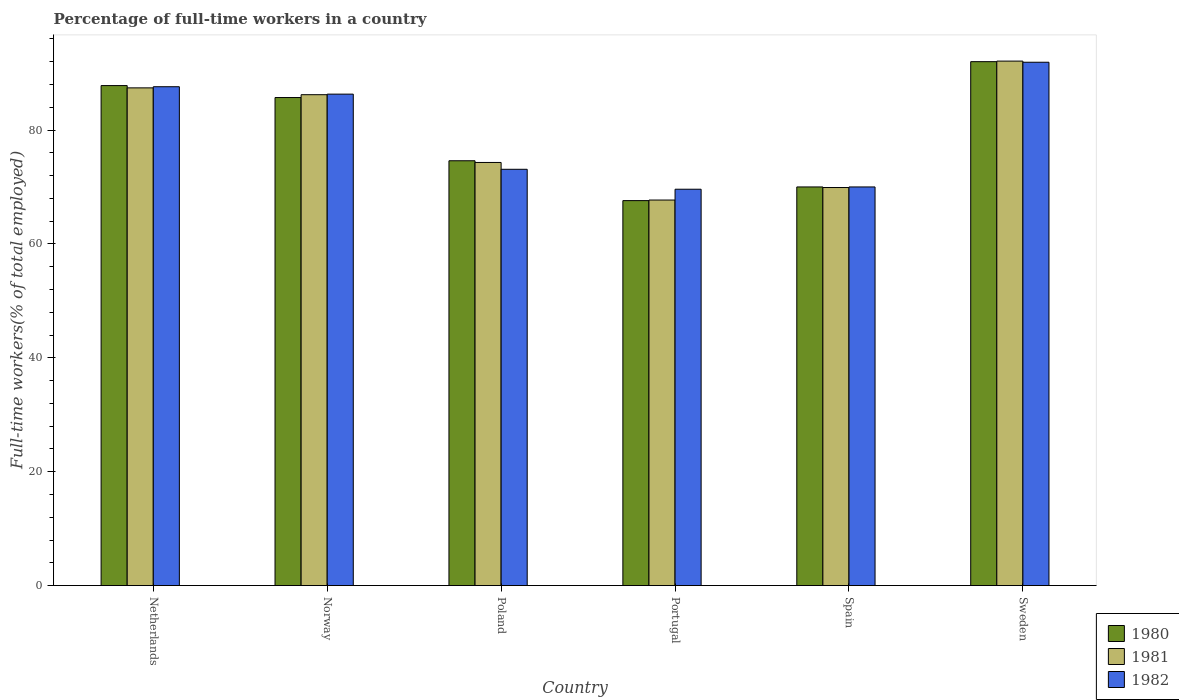How many different coloured bars are there?
Your answer should be very brief. 3. Are the number of bars on each tick of the X-axis equal?
Keep it short and to the point. Yes. How many bars are there on the 3rd tick from the right?
Your answer should be very brief. 3. What is the label of the 5th group of bars from the left?
Provide a succinct answer. Spain. What is the percentage of full-time workers in 1981 in Poland?
Provide a succinct answer. 74.3. Across all countries, what is the maximum percentage of full-time workers in 1982?
Offer a very short reply. 91.9. Across all countries, what is the minimum percentage of full-time workers in 1981?
Make the answer very short. 67.7. What is the total percentage of full-time workers in 1981 in the graph?
Your answer should be very brief. 477.6. What is the difference between the percentage of full-time workers in 1982 in Netherlands and that in Spain?
Your answer should be very brief. 17.6. What is the average percentage of full-time workers in 1982 per country?
Provide a succinct answer. 79.75. What is the difference between the percentage of full-time workers of/in 1981 and percentage of full-time workers of/in 1980 in Poland?
Your response must be concise. -0.3. In how many countries, is the percentage of full-time workers in 1980 greater than 4 %?
Give a very brief answer. 6. What is the ratio of the percentage of full-time workers in 1980 in Netherlands to that in Portugal?
Provide a short and direct response. 1.3. Is the percentage of full-time workers in 1980 in Norway less than that in Portugal?
Your response must be concise. No. What is the difference between the highest and the second highest percentage of full-time workers in 1981?
Ensure brevity in your answer.  5.9. What is the difference between the highest and the lowest percentage of full-time workers in 1982?
Offer a terse response. 22.3. In how many countries, is the percentage of full-time workers in 1980 greater than the average percentage of full-time workers in 1980 taken over all countries?
Make the answer very short. 3. What does the 1st bar from the left in Spain represents?
Offer a very short reply. 1980. What does the 3rd bar from the right in Norway represents?
Give a very brief answer. 1980. Is it the case that in every country, the sum of the percentage of full-time workers in 1981 and percentage of full-time workers in 1980 is greater than the percentage of full-time workers in 1982?
Keep it short and to the point. Yes. How many bars are there?
Offer a very short reply. 18. What is the difference between two consecutive major ticks on the Y-axis?
Provide a short and direct response. 20. Does the graph contain any zero values?
Make the answer very short. No. Where does the legend appear in the graph?
Your response must be concise. Bottom right. How are the legend labels stacked?
Keep it short and to the point. Vertical. What is the title of the graph?
Keep it short and to the point. Percentage of full-time workers in a country. Does "1980" appear as one of the legend labels in the graph?
Give a very brief answer. Yes. What is the label or title of the X-axis?
Offer a very short reply. Country. What is the label or title of the Y-axis?
Your answer should be very brief. Full-time workers(% of total employed). What is the Full-time workers(% of total employed) in 1980 in Netherlands?
Provide a succinct answer. 87.8. What is the Full-time workers(% of total employed) of 1981 in Netherlands?
Keep it short and to the point. 87.4. What is the Full-time workers(% of total employed) of 1982 in Netherlands?
Ensure brevity in your answer.  87.6. What is the Full-time workers(% of total employed) of 1980 in Norway?
Your answer should be compact. 85.7. What is the Full-time workers(% of total employed) of 1981 in Norway?
Offer a terse response. 86.2. What is the Full-time workers(% of total employed) of 1982 in Norway?
Your answer should be compact. 86.3. What is the Full-time workers(% of total employed) of 1980 in Poland?
Offer a terse response. 74.6. What is the Full-time workers(% of total employed) in 1981 in Poland?
Keep it short and to the point. 74.3. What is the Full-time workers(% of total employed) of 1982 in Poland?
Provide a succinct answer. 73.1. What is the Full-time workers(% of total employed) of 1980 in Portugal?
Keep it short and to the point. 67.6. What is the Full-time workers(% of total employed) in 1981 in Portugal?
Your answer should be compact. 67.7. What is the Full-time workers(% of total employed) in 1982 in Portugal?
Keep it short and to the point. 69.6. What is the Full-time workers(% of total employed) of 1981 in Spain?
Provide a short and direct response. 69.9. What is the Full-time workers(% of total employed) of 1980 in Sweden?
Provide a succinct answer. 92. What is the Full-time workers(% of total employed) in 1981 in Sweden?
Your answer should be very brief. 92.1. What is the Full-time workers(% of total employed) of 1982 in Sweden?
Offer a terse response. 91.9. Across all countries, what is the maximum Full-time workers(% of total employed) of 1980?
Your answer should be very brief. 92. Across all countries, what is the maximum Full-time workers(% of total employed) of 1981?
Your answer should be compact. 92.1. Across all countries, what is the maximum Full-time workers(% of total employed) of 1982?
Offer a very short reply. 91.9. Across all countries, what is the minimum Full-time workers(% of total employed) of 1980?
Your answer should be compact. 67.6. Across all countries, what is the minimum Full-time workers(% of total employed) of 1981?
Make the answer very short. 67.7. Across all countries, what is the minimum Full-time workers(% of total employed) in 1982?
Your answer should be very brief. 69.6. What is the total Full-time workers(% of total employed) in 1980 in the graph?
Offer a very short reply. 477.7. What is the total Full-time workers(% of total employed) of 1981 in the graph?
Your answer should be compact. 477.6. What is the total Full-time workers(% of total employed) in 1982 in the graph?
Your answer should be compact. 478.5. What is the difference between the Full-time workers(% of total employed) of 1980 in Netherlands and that in Norway?
Provide a short and direct response. 2.1. What is the difference between the Full-time workers(% of total employed) of 1981 in Netherlands and that in Norway?
Make the answer very short. 1.2. What is the difference between the Full-time workers(% of total employed) of 1982 in Netherlands and that in Norway?
Your response must be concise. 1.3. What is the difference between the Full-time workers(% of total employed) of 1980 in Netherlands and that in Poland?
Provide a short and direct response. 13.2. What is the difference between the Full-time workers(% of total employed) in 1981 in Netherlands and that in Poland?
Make the answer very short. 13.1. What is the difference between the Full-time workers(% of total employed) of 1982 in Netherlands and that in Poland?
Give a very brief answer. 14.5. What is the difference between the Full-time workers(% of total employed) of 1980 in Netherlands and that in Portugal?
Provide a succinct answer. 20.2. What is the difference between the Full-time workers(% of total employed) of 1981 in Netherlands and that in Portugal?
Make the answer very short. 19.7. What is the difference between the Full-time workers(% of total employed) of 1982 in Netherlands and that in Portugal?
Provide a succinct answer. 18. What is the difference between the Full-time workers(% of total employed) in 1980 in Netherlands and that in Spain?
Give a very brief answer. 17.8. What is the difference between the Full-time workers(% of total employed) in 1981 in Netherlands and that in Spain?
Keep it short and to the point. 17.5. What is the difference between the Full-time workers(% of total employed) of 1980 in Netherlands and that in Sweden?
Your answer should be compact. -4.2. What is the difference between the Full-time workers(% of total employed) of 1982 in Netherlands and that in Sweden?
Your answer should be compact. -4.3. What is the difference between the Full-time workers(% of total employed) of 1980 in Norway and that in Poland?
Offer a very short reply. 11.1. What is the difference between the Full-time workers(% of total employed) of 1982 in Norway and that in Poland?
Your answer should be very brief. 13.2. What is the difference between the Full-time workers(% of total employed) of 1980 in Norway and that in Portugal?
Offer a very short reply. 18.1. What is the difference between the Full-time workers(% of total employed) in 1981 in Norway and that in Portugal?
Your answer should be compact. 18.5. What is the difference between the Full-time workers(% of total employed) of 1982 in Norway and that in Portugal?
Provide a short and direct response. 16.7. What is the difference between the Full-time workers(% of total employed) in 1982 in Norway and that in Spain?
Ensure brevity in your answer.  16.3. What is the difference between the Full-time workers(% of total employed) of 1980 in Norway and that in Sweden?
Your answer should be very brief. -6.3. What is the difference between the Full-time workers(% of total employed) in 1982 in Poland and that in Portugal?
Your answer should be very brief. 3.5. What is the difference between the Full-time workers(% of total employed) of 1982 in Poland and that in Spain?
Ensure brevity in your answer.  3.1. What is the difference between the Full-time workers(% of total employed) of 1980 in Poland and that in Sweden?
Provide a short and direct response. -17.4. What is the difference between the Full-time workers(% of total employed) of 1981 in Poland and that in Sweden?
Make the answer very short. -17.8. What is the difference between the Full-time workers(% of total employed) in 1982 in Poland and that in Sweden?
Keep it short and to the point. -18.8. What is the difference between the Full-time workers(% of total employed) of 1981 in Portugal and that in Spain?
Give a very brief answer. -2.2. What is the difference between the Full-time workers(% of total employed) of 1980 in Portugal and that in Sweden?
Ensure brevity in your answer.  -24.4. What is the difference between the Full-time workers(% of total employed) in 1981 in Portugal and that in Sweden?
Ensure brevity in your answer.  -24.4. What is the difference between the Full-time workers(% of total employed) of 1982 in Portugal and that in Sweden?
Offer a terse response. -22.3. What is the difference between the Full-time workers(% of total employed) of 1981 in Spain and that in Sweden?
Provide a succinct answer. -22.2. What is the difference between the Full-time workers(% of total employed) of 1982 in Spain and that in Sweden?
Offer a terse response. -21.9. What is the difference between the Full-time workers(% of total employed) of 1980 in Netherlands and the Full-time workers(% of total employed) of 1981 in Norway?
Your answer should be very brief. 1.6. What is the difference between the Full-time workers(% of total employed) of 1980 in Netherlands and the Full-time workers(% of total employed) of 1981 in Poland?
Offer a very short reply. 13.5. What is the difference between the Full-time workers(% of total employed) of 1980 in Netherlands and the Full-time workers(% of total employed) of 1982 in Poland?
Your answer should be very brief. 14.7. What is the difference between the Full-time workers(% of total employed) in 1980 in Netherlands and the Full-time workers(% of total employed) in 1981 in Portugal?
Offer a very short reply. 20.1. What is the difference between the Full-time workers(% of total employed) in 1980 in Netherlands and the Full-time workers(% of total employed) in 1982 in Portugal?
Provide a short and direct response. 18.2. What is the difference between the Full-time workers(% of total employed) in 1981 in Netherlands and the Full-time workers(% of total employed) in 1982 in Sweden?
Your answer should be very brief. -4.5. What is the difference between the Full-time workers(% of total employed) in 1980 in Norway and the Full-time workers(% of total employed) in 1981 in Poland?
Offer a terse response. 11.4. What is the difference between the Full-time workers(% of total employed) of 1980 in Norway and the Full-time workers(% of total employed) of 1982 in Poland?
Make the answer very short. 12.6. What is the difference between the Full-time workers(% of total employed) in 1981 in Norway and the Full-time workers(% of total employed) in 1982 in Poland?
Give a very brief answer. 13.1. What is the difference between the Full-time workers(% of total employed) of 1981 in Norway and the Full-time workers(% of total employed) of 1982 in Sweden?
Give a very brief answer. -5.7. What is the difference between the Full-time workers(% of total employed) in 1980 in Poland and the Full-time workers(% of total employed) in 1981 in Portugal?
Give a very brief answer. 6.9. What is the difference between the Full-time workers(% of total employed) of 1980 in Poland and the Full-time workers(% of total employed) of 1982 in Spain?
Offer a very short reply. 4.6. What is the difference between the Full-time workers(% of total employed) of 1981 in Poland and the Full-time workers(% of total employed) of 1982 in Spain?
Make the answer very short. 4.3. What is the difference between the Full-time workers(% of total employed) of 1980 in Poland and the Full-time workers(% of total employed) of 1981 in Sweden?
Give a very brief answer. -17.5. What is the difference between the Full-time workers(% of total employed) of 1980 in Poland and the Full-time workers(% of total employed) of 1982 in Sweden?
Provide a succinct answer. -17.3. What is the difference between the Full-time workers(% of total employed) of 1981 in Poland and the Full-time workers(% of total employed) of 1982 in Sweden?
Your response must be concise. -17.6. What is the difference between the Full-time workers(% of total employed) in 1980 in Portugal and the Full-time workers(% of total employed) in 1982 in Spain?
Make the answer very short. -2.4. What is the difference between the Full-time workers(% of total employed) of 1981 in Portugal and the Full-time workers(% of total employed) of 1982 in Spain?
Your answer should be very brief. -2.3. What is the difference between the Full-time workers(% of total employed) of 1980 in Portugal and the Full-time workers(% of total employed) of 1981 in Sweden?
Your answer should be compact. -24.5. What is the difference between the Full-time workers(% of total employed) of 1980 in Portugal and the Full-time workers(% of total employed) of 1982 in Sweden?
Your response must be concise. -24.3. What is the difference between the Full-time workers(% of total employed) of 1981 in Portugal and the Full-time workers(% of total employed) of 1982 in Sweden?
Your answer should be very brief. -24.2. What is the difference between the Full-time workers(% of total employed) of 1980 in Spain and the Full-time workers(% of total employed) of 1981 in Sweden?
Keep it short and to the point. -22.1. What is the difference between the Full-time workers(% of total employed) of 1980 in Spain and the Full-time workers(% of total employed) of 1982 in Sweden?
Give a very brief answer. -21.9. What is the difference between the Full-time workers(% of total employed) in 1981 in Spain and the Full-time workers(% of total employed) in 1982 in Sweden?
Provide a short and direct response. -22. What is the average Full-time workers(% of total employed) in 1980 per country?
Your answer should be very brief. 79.62. What is the average Full-time workers(% of total employed) of 1981 per country?
Offer a very short reply. 79.6. What is the average Full-time workers(% of total employed) in 1982 per country?
Ensure brevity in your answer.  79.75. What is the difference between the Full-time workers(% of total employed) in 1980 and Full-time workers(% of total employed) in 1981 in Netherlands?
Your answer should be very brief. 0.4. What is the difference between the Full-time workers(% of total employed) in 1980 and Full-time workers(% of total employed) in 1982 in Netherlands?
Provide a succinct answer. 0.2. What is the difference between the Full-time workers(% of total employed) in 1981 and Full-time workers(% of total employed) in 1982 in Netherlands?
Your answer should be very brief. -0.2. What is the difference between the Full-time workers(% of total employed) in 1980 and Full-time workers(% of total employed) in 1981 in Norway?
Keep it short and to the point. -0.5. What is the difference between the Full-time workers(% of total employed) of 1980 and Full-time workers(% of total employed) of 1982 in Norway?
Give a very brief answer. -0.6. What is the difference between the Full-time workers(% of total employed) of 1981 and Full-time workers(% of total employed) of 1982 in Poland?
Give a very brief answer. 1.2. What is the difference between the Full-time workers(% of total employed) in 1980 and Full-time workers(% of total employed) in 1981 in Portugal?
Provide a short and direct response. -0.1. What is the difference between the Full-time workers(% of total employed) of 1981 and Full-time workers(% of total employed) of 1982 in Portugal?
Provide a short and direct response. -1.9. What is the difference between the Full-time workers(% of total employed) in 1980 and Full-time workers(% of total employed) in 1981 in Spain?
Your answer should be compact. 0.1. What is the difference between the Full-time workers(% of total employed) of 1980 and Full-time workers(% of total employed) of 1981 in Sweden?
Your answer should be compact. -0.1. What is the ratio of the Full-time workers(% of total employed) of 1980 in Netherlands to that in Norway?
Provide a short and direct response. 1.02. What is the ratio of the Full-time workers(% of total employed) of 1981 in Netherlands to that in Norway?
Give a very brief answer. 1.01. What is the ratio of the Full-time workers(% of total employed) in 1982 in Netherlands to that in Norway?
Give a very brief answer. 1.02. What is the ratio of the Full-time workers(% of total employed) of 1980 in Netherlands to that in Poland?
Make the answer very short. 1.18. What is the ratio of the Full-time workers(% of total employed) of 1981 in Netherlands to that in Poland?
Offer a terse response. 1.18. What is the ratio of the Full-time workers(% of total employed) of 1982 in Netherlands to that in Poland?
Your response must be concise. 1.2. What is the ratio of the Full-time workers(% of total employed) in 1980 in Netherlands to that in Portugal?
Your answer should be very brief. 1.3. What is the ratio of the Full-time workers(% of total employed) of 1981 in Netherlands to that in Portugal?
Your answer should be very brief. 1.29. What is the ratio of the Full-time workers(% of total employed) in 1982 in Netherlands to that in Portugal?
Offer a very short reply. 1.26. What is the ratio of the Full-time workers(% of total employed) of 1980 in Netherlands to that in Spain?
Your answer should be very brief. 1.25. What is the ratio of the Full-time workers(% of total employed) of 1981 in Netherlands to that in Spain?
Give a very brief answer. 1.25. What is the ratio of the Full-time workers(% of total employed) of 1982 in Netherlands to that in Spain?
Provide a succinct answer. 1.25. What is the ratio of the Full-time workers(% of total employed) of 1980 in Netherlands to that in Sweden?
Provide a short and direct response. 0.95. What is the ratio of the Full-time workers(% of total employed) in 1981 in Netherlands to that in Sweden?
Provide a succinct answer. 0.95. What is the ratio of the Full-time workers(% of total employed) of 1982 in Netherlands to that in Sweden?
Your answer should be compact. 0.95. What is the ratio of the Full-time workers(% of total employed) of 1980 in Norway to that in Poland?
Ensure brevity in your answer.  1.15. What is the ratio of the Full-time workers(% of total employed) in 1981 in Norway to that in Poland?
Your answer should be very brief. 1.16. What is the ratio of the Full-time workers(% of total employed) in 1982 in Norway to that in Poland?
Provide a short and direct response. 1.18. What is the ratio of the Full-time workers(% of total employed) in 1980 in Norway to that in Portugal?
Offer a very short reply. 1.27. What is the ratio of the Full-time workers(% of total employed) of 1981 in Norway to that in Portugal?
Your answer should be very brief. 1.27. What is the ratio of the Full-time workers(% of total employed) in 1982 in Norway to that in Portugal?
Your answer should be compact. 1.24. What is the ratio of the Full-time workers(% of total employed) of 1980 in Norway to that in Spain?
Provide a short and direct response. 1.22. What is the ratio of the Full-time workers(% of total employed) of 1981 in Norway to that in Spain?
Give a very brief answer. 1.23. What is the ratio of the Full-time workers(% of total employed) in 1982 in Norway to that in Spain?
Provide a short and direct response. 1.23. What is the ratio of the Full-time workers(% of total employed) of 1980 in Norway to that in Sweden?
Offer a very short reply. 0.93. What is the ratio of the Full-time workers(% of total employed) in 1981 in Norway to that in Sweden?
Provide a short and direct response. 0.94. What is the ratio of the Full-time workers(% of total employed) of 1982 in Norway to that in Sweden?
Keep it short and to the point. 0.94. What is the ratio of the Full-time workers(% of total employed) in 1980 in Poland to that in Portugal?
Give a very brief answer. 1.1. What is the ratio of the Full-time workers(% of total employed) of 1981 in Poland to that in Portugal?
Your answer should be compact. 1.1. What is the ratio of the Full-time workers(% of total employed) of 1982 in Poland to that in Portugal?
Your answer should be compact. 1.05. What is the ratio of the Full-time workers(% of total employed) in 1980 in Poland to that in Spain?
Make the answer very short. 1.07. What is the ratio of the Full-time workers(% of total employed) in 1981 in Poland to that in Spain?
Your answer should be very brief. 1.06. What is the ratio of the Full-time workers(% of total employed) in 1982 in Poland to that in Spain?
Provide a short and direct response. 1.04. What is the ratio of the Full-time workers(% of total employed) in 1980 in Poland to that in Sweden?
Make the answer very short. 0.81. What is the ratio of the Full-time workers(% of total employed) of 1981 in Poland to that in Sweden?
Your answer should be very brief. 0.81. What is the ratio of the Full-time workers(% of total employed) in 1982 in Poland to that in Sweden?
Make the answer very short. 0.8. What is the ratio of the Full-time workers(% of total employed) of 1980 in Portugal to that in Spain?
Offer a terse response. 0.97. What is the ratio of the Full-time workers(% of total employed) in 1981 in Portugal to that in Spain?
Keep it short and to the point. 0.97. What is the ratio of the Full-time workers(% of total employed) in 1980 in Portugal to that in Sweden?
Make the answer very short. 0.73. What is the ratio of the Full-time workers(% of total employed) in 1981 in Portugal to that in Sweden?
Your answer should be compact. 0.74. What is the ratio of the Full-time workers(% of total employed) in 1982 in Portugal to that in Sweden?
Provide a succinct answer. 0.76. What is the ratio of the Full-time workers(% of total employed) in 1980 in Spain to that in Sweden?
Give a very brief answer. 0.76. What is the ratio of the Full-time workers(% of total employed) of 1981 in Spain to that in Sweden?
Your answer should be very brief. 0.76. What is the ratio of the Full-time workers(% of total employed) of 1982 in Spain to that in Sweden?
Offer a terse response. 0.76. What is the difference between the highest and the second highest Full-time workers(% of total employed) of 1980?
Your answer should be compact. 4.2. What is the difference between the highest and the second highest Full-time workers(% of total employed) in 1981?
Keep it short and to the point. 4.7. What is the difference between the highest and the lowest Full-time workers(% of total employed) of 1980?
Give a very brief answer. 24.4. What is the difference between the highest and the lowest Full-time workers(% of total employed) in 1981?
Provide a succinct answer. 24.4. What is the difference between the highest and the lowest Full-time workers(% of total employed) of 1982?
Your answer should be compact. 22.3. 